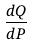Convert formula to latex. <formula><loc_0><loc_0><loc_500><loc_500>\frac { d Q } { d P }</formula> 